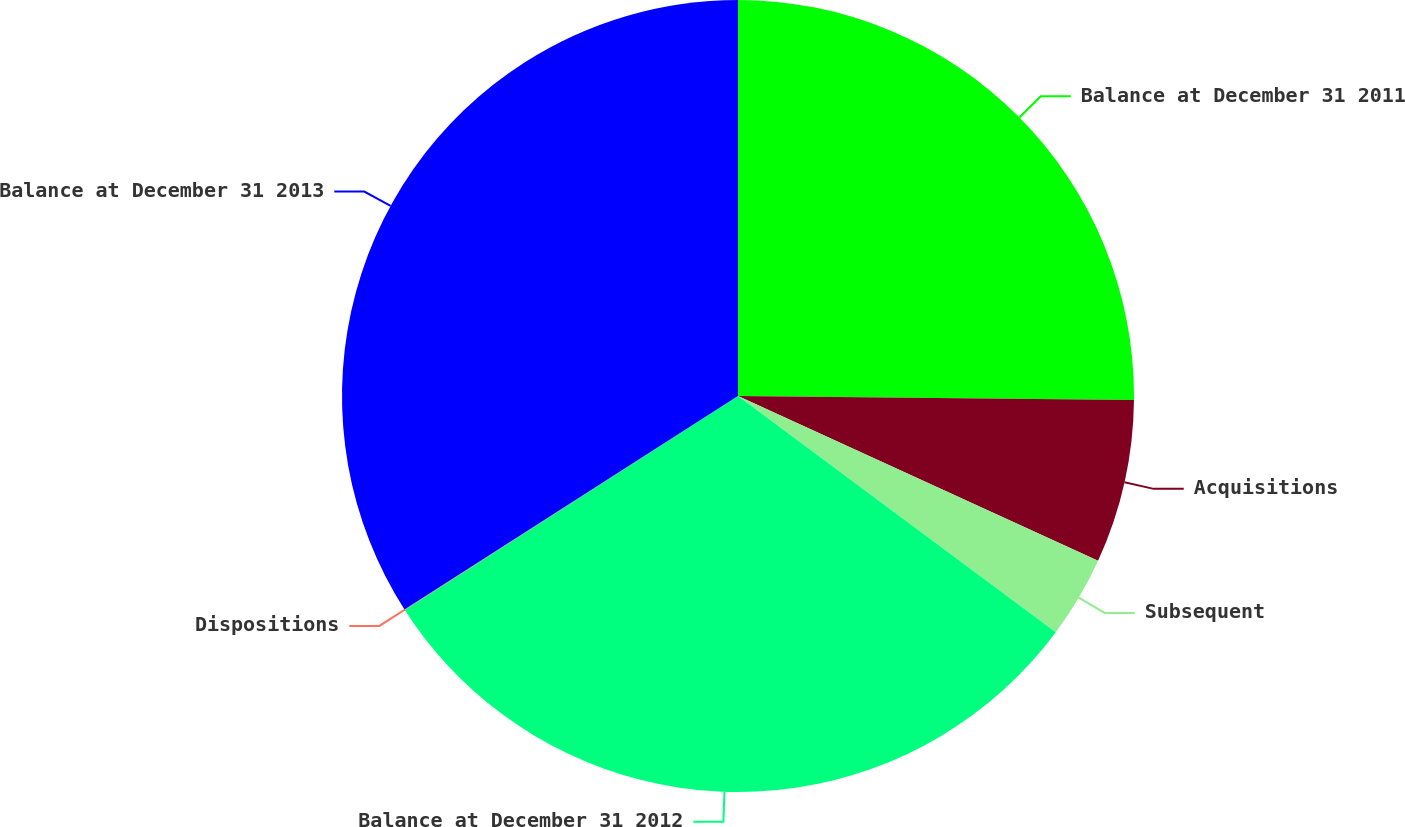Convert chart. <chart><loc_0><loc_0><loc_500><loc_500><pie_chart><fcel>Balance at December 31 2011<fcel>Acquisitions<fcel>Subsequent<fcel>Balance at December 31 2012<fcel>Dispositions<fcel>Balance at December 31 2013<nl><fcel>25.16%<fcel>6.67%<fcel>3.34%<fcel>30.74%<fcel>0.02%<fcel>34.06%<nl></chart> 